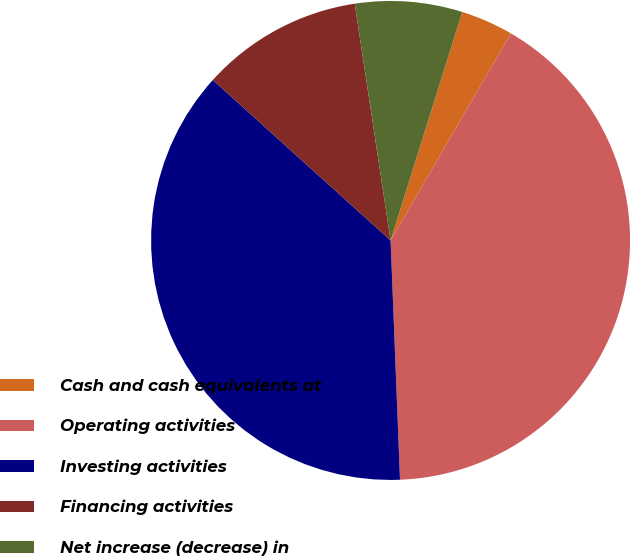<chart> <loc_0><loc_0><loc_500><loc_500><pie_chart><fcel>Cash and cash equivalents at<fcel>Operating activities<fcel>Investing activities<fcel>Financing activities<fcel>Net increase (decrease) in<nl><fcel>3.54%<fcel>40.99%<fcel>37.31%<fcel>10.92%<fcel>7.23%<nl></chart> 